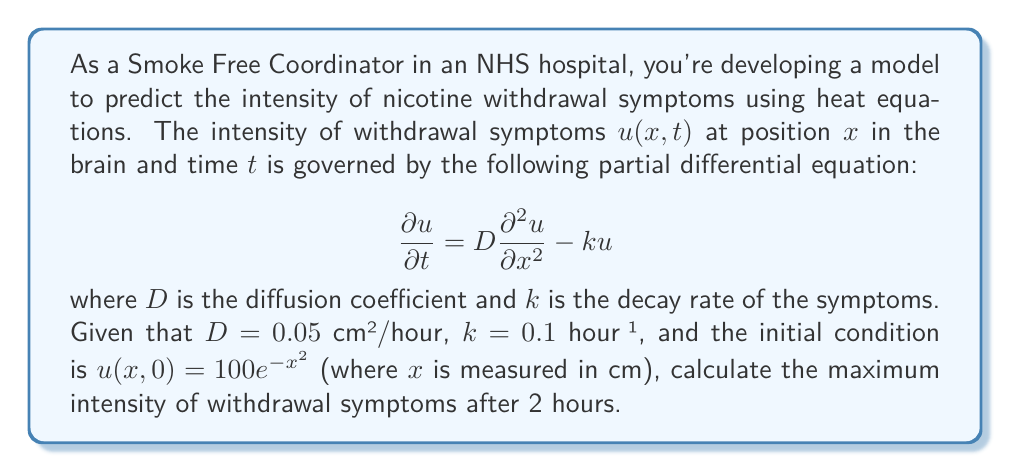Show me your answer to this math problem. To solve this problem, we need to use the solution of the heat equation with decay:

1) The general solution for this equation is:

   $$u(x,t) = \frac{1}{\sqrt{4\pi Dt}} \int_{-\infty}^{\infty} u(\xi,0) e^{-\frac{(x-\xi)^2}{4Dt}} e^{-kt} d\xi$$

2) Substituting our initial condition $u(x,0) = 100e^{-x^2}$:

   $$u(x,t) = \frac{100}{\sqrt{4\pi Dt}} \int_{-\infty}^{\infty} e^{-\xi^2} e^{-\frac{(x-\xi)^2}{4Dt}} e^{-kt} d\xi$$

3) This integral can be evaluated to give:

   $$u(x,t) = \frac{100}{\sqrt{1+4Dt}} e^{-\frac{x^2}{1+4Dt}} e^{-kt}$$

4) To find the maximum intensity, we need to find where $\frac{\partial u}{\partial x} = 0$:

   $$\frac{\partial u}{\partial x} = -\frac{200x}{(1+4Dt)^{3/2}} e^{-\frac{x^2}{1+4Dt}} e^{-kt}$$

5) This is zero when $x = 0$, which gives the maximum intensity:

   $$u_{max}(t) = u(0,t) = \frac{100}{\sqrt{1+4Dt}} e^{-kt}$$

6) Substituting the given values ($D = 0.05$ cm²/hour, $k = 0.1$ hour⁻¹, $t = 2$ hours):

   $$u_{max}(2) = \frac{100}{\sqrt{1+4(0.05)(2)}} e^{-(0.1)(2)}$$

7) Calculating:

   $$u_{max}(2) = \frac{100}{\sqrt{1.4}} e^{-0.2} \approx 69.33$$

Therefore, the maximum intensity of withdrawal symptoms after 2 hours is approximately 69.33 units.
Answer: 69.33 units (rounded to two decimal places) 